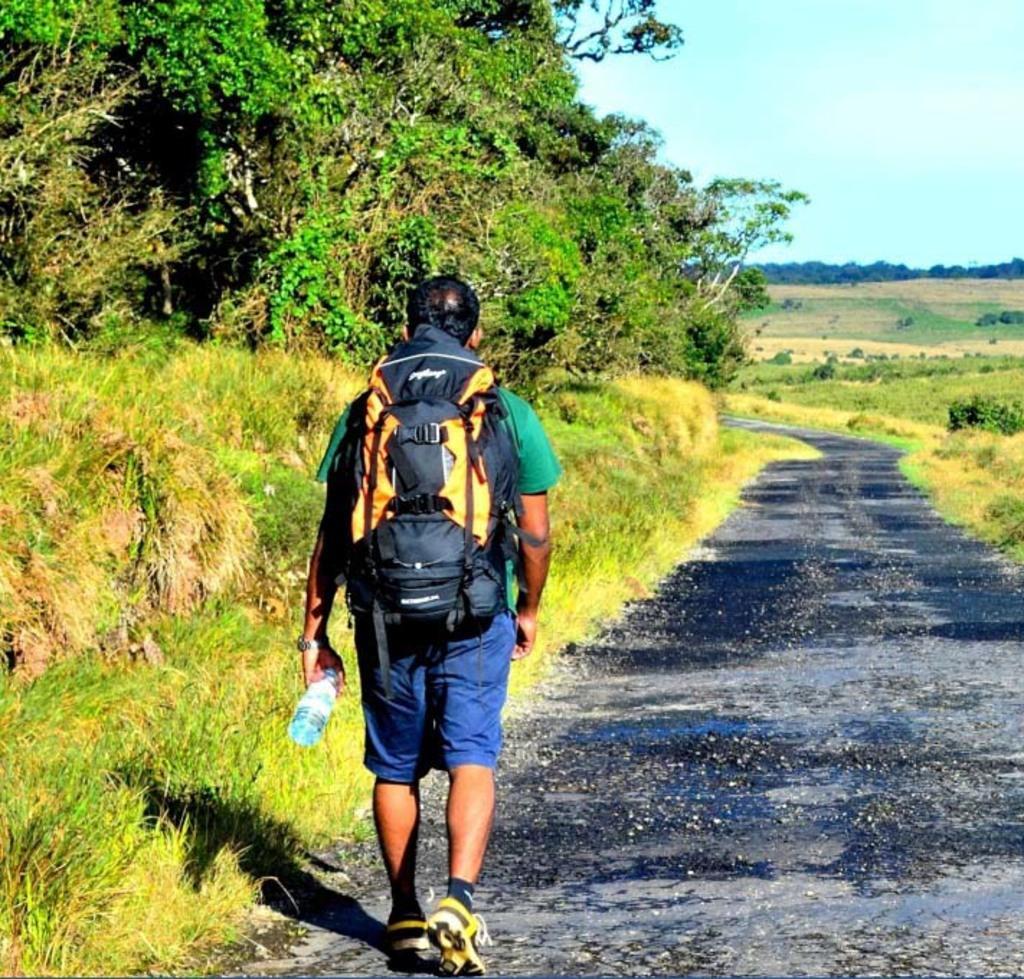How would you summarize this image in a sentence or two? This is the picture of a road. In the both side of the road there are greenery. There are grass. In the left side we can see trees. In the middle a person is walking by this road. He wearing a blue shorts a green t shirt and carrying a backpack. He is holding a water bottle in his left hand and a watch is there in his left hand. He is wearing shoes. The sky is clear. Far away in the background we can see many trees. 